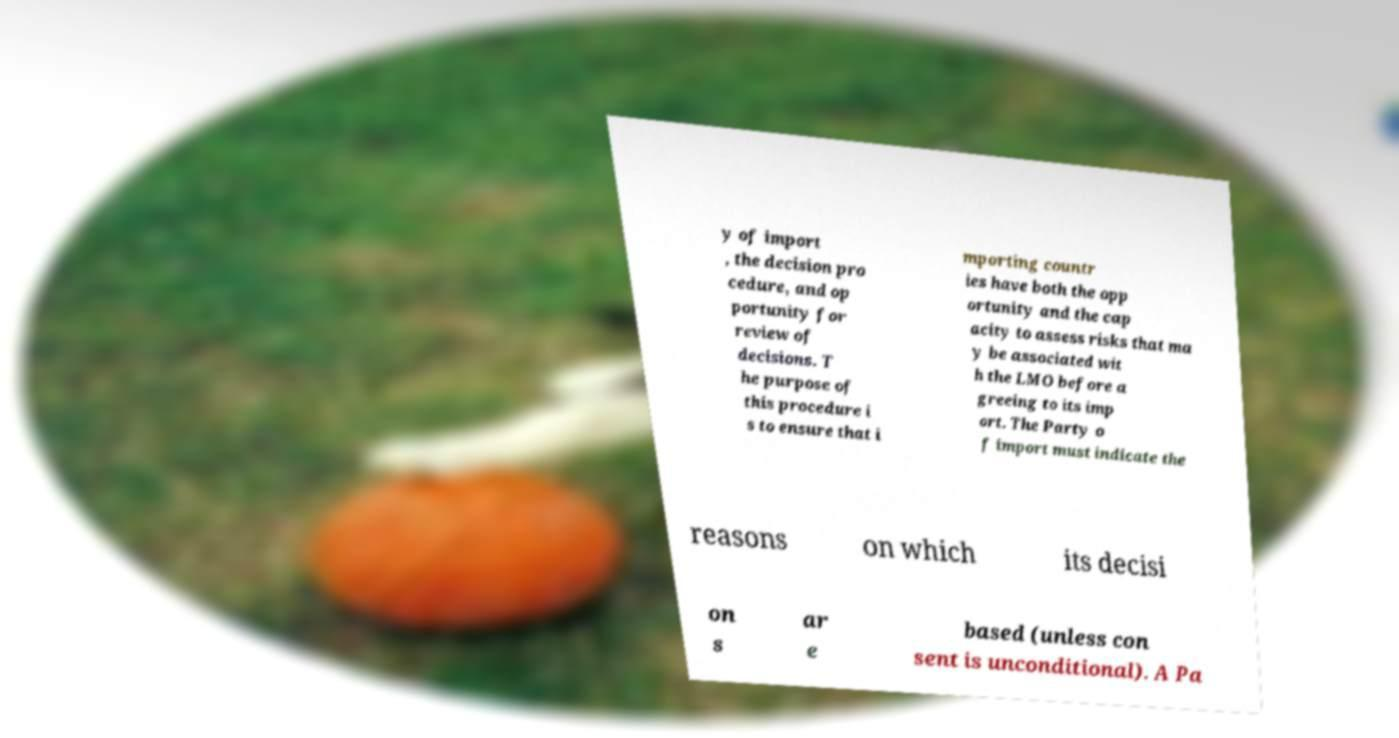Could you extract and type out the text from this image? y of import , the decision pro cedure, and op portunity for review of decisions. T he purpose of this procedure i s to ensure that i mporting countr ies have both the opp ortunity and the cap acity to assess risks that ma y be associated wit h the LMO before a greeing to its imp ort. The Party o f import must indicate the reasons on which its decisi on s ar e based (unless con sent is unconditional). A Pa 